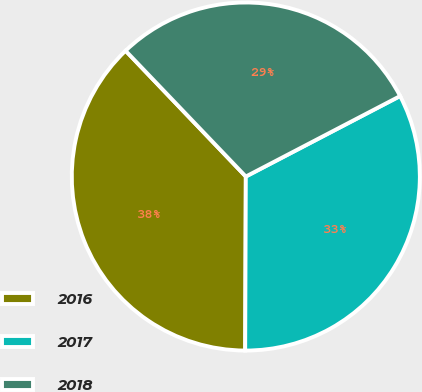<chart> <loc_0><loc_0><loc_500><loc_500><pie_chart><fcel>2016<fcel>2017<fcel>2018<nl><fcel>37.8%<fcel>32.71%<fcel>29.49%<nl></chart> 